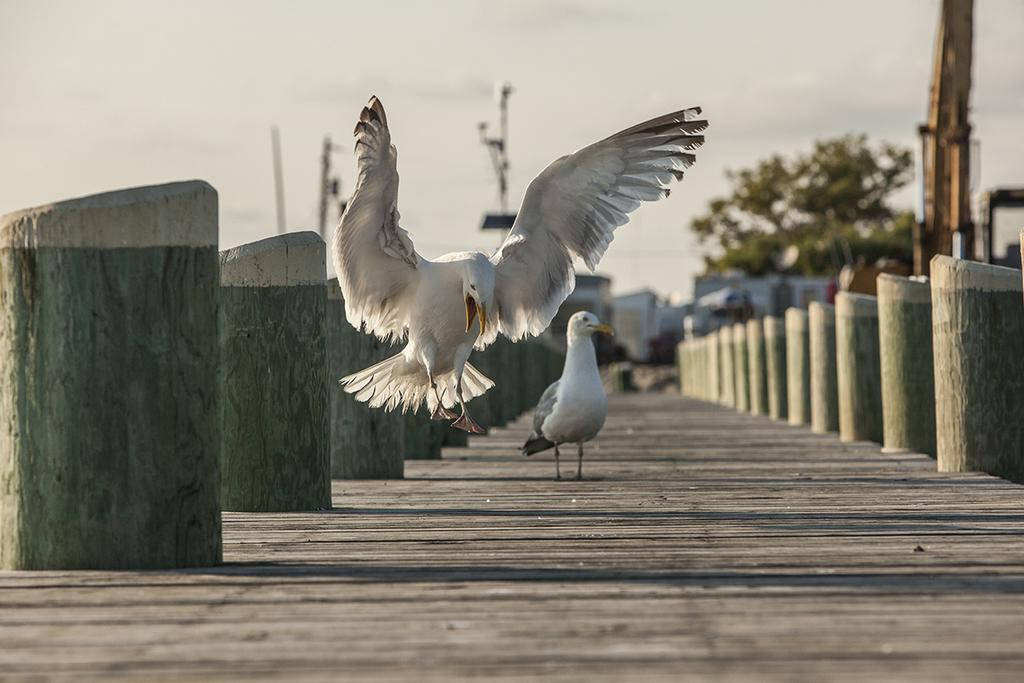What is located in the center of the image? There are birds in the center of the image. What can be seen in the background of the image? There are buildings and a tree in the background of the image. What is the condition of the sky in the image? The sky is cloudy in the image. What structures are present in the image? There are poles and pillars in the image. What type of dinner is being served in the image? There is no dinner present in the image; it features birds, buildings, a tree, and cloudy sky. What emotion can be seen on the faces of the birds in the image? There are no faces on the birds in the image, so it is not possible to determine their emotions. 